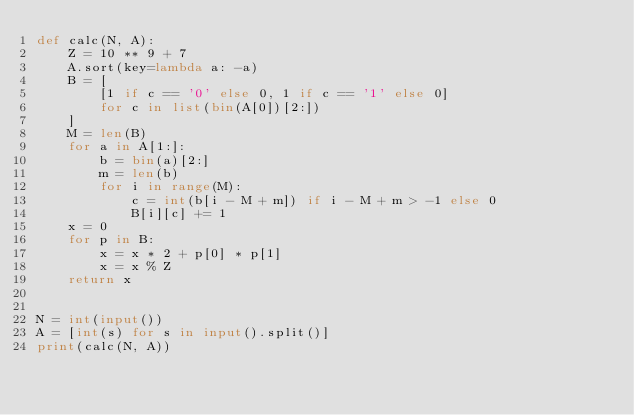<code> <loc_0><loc_0><loc_500><loc_500><_Python_>def calc(N, A):
    Z = 10 ** 9 + 7
    A.sort(key=lambda a: -a)
    B = [
        [1 if c == '0' else 0, 1 if c == '1' else 0]
        for c in list(bin(A[0])[2:])
    ]
    M = len(B)
    for a in A[1:]:
        b = bin(a)[2:]
        m = len(b)
        for i in range(M):
            c = int(b[i - M + m]) if i - M + m > -1 else 0
            B[i][c] += 1
    x = 0
    for p in B:
        x = x * 2 + p[0] * p[1]
        x = x % Z
    return x


N = int(input())
A = [int(s) for s in input().split()]
print(calc(N, A))</code> 